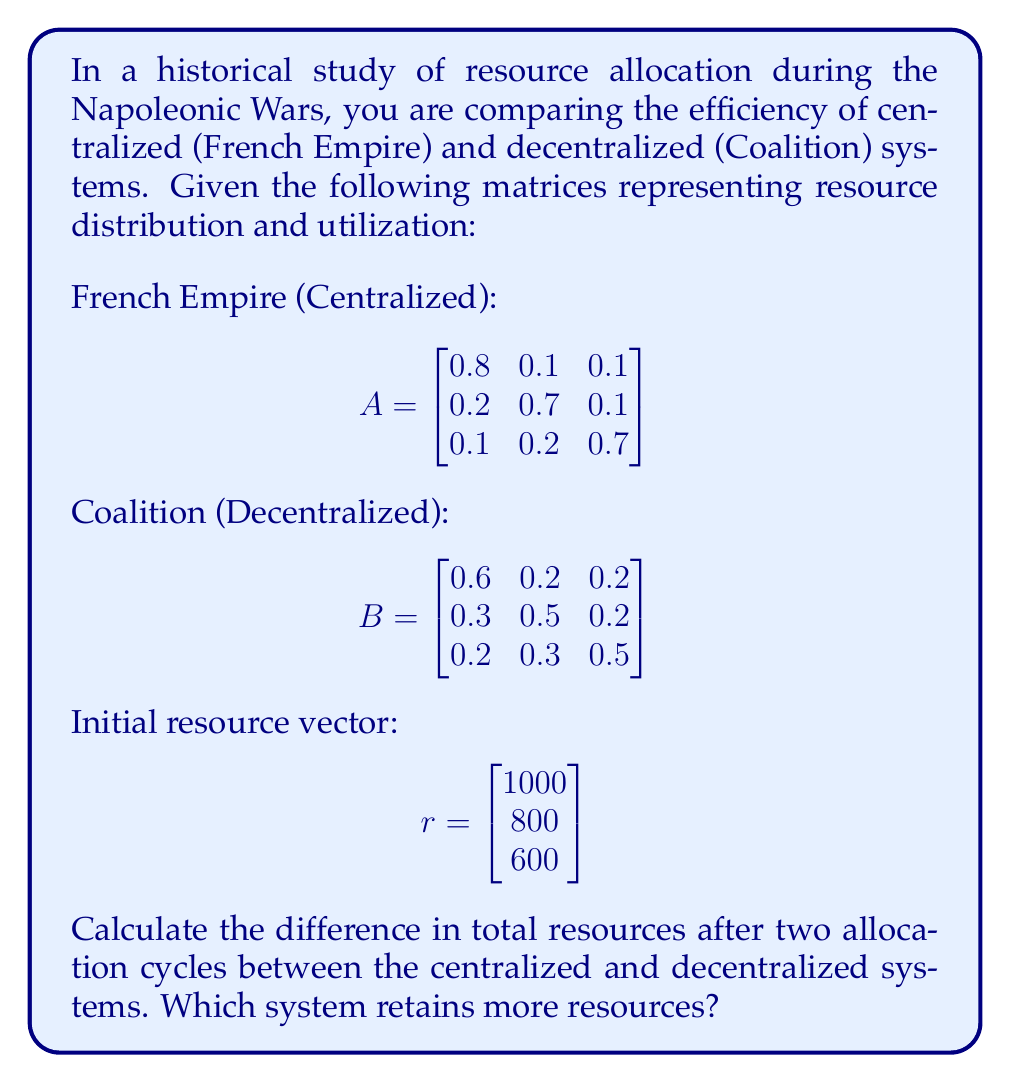Could you help me with this problem? To solve this problem, we need to follow these steps:

1) First, we calculate the resource distribution after two cycles for each system.

2) For the French Empire (Centralized):
   $$r_1 = A \cdot r$$
   $$r_2 = A \cdot r_1 = A \cdot (A \cdot r) = A^2 \cdot r$$

3) For the Coalition (Decentralized):
   $$r_1 = B \cdot r$$
   $$r_2 = B \cdot r_1 = B \cdot (B \cdot r) = B^2 \cdot r$$

4) Let's calculate $A^2$ and $B^2$:

   $$A^2 = \begin{bmatrix}
   0.67 & 0.17 & 0.16 \\
   0.29 & 0.54 & 0.17 \\
   0.19 & 0.29 & 0.52
   \end{bmatrix}$$

   $$B^2 = \begin{bmatrix}
   0.43 & 0.29 & 0.28 \\
   0.36 & 0.38 & 0.26 \\
   0.31 & 0.35 & 0.34
   \end{bmatrix}$$

5) Now, we can calculate the final resource vectors:

   For French Empire: 
   $$r_F = A^2 \cdot r = \begin{bmatrix}
   670 & 170 & 160 \\
   290 & 540 & 170 \\
   190 & 290 & 520
   \end{bmatrix} \cdot \begin{bmatrix}
   1000 \\
   800 \\
   600
   \end{bmatrix} = \begin{bmatrix}
   1006 \\
   866 \\
   710
   \end{bmatrix}$$

   For Coalition:
   $$r_C = B^2 \cdot r = \begin{bmatrix}
   430 & 290 & 280 \\
   360 & 380 & 260 \\
   310 & 350 & 340
   \end{bmatrix} \cdot \begin{bmatrix}
   1000 \\
   800 \\
   600
   \end{bmatrix} = \begin{bmatrix}
   874 \\
   848 \\
   818
   \end{bmatrix}$$

6) To find the total resources in each system, we sum the elements of each vector:

   French Empire: $1006 + 866 + 710 = 2582$
   Coalition: $874 + 848 + 818 = 2540$

7) The difference is: $2582 - 2540 = 42$

The centralized system (French Empire) retains 42 more resources than the decentralized system (Coalition).
Answer: The centralized system retains 42 more resources. 